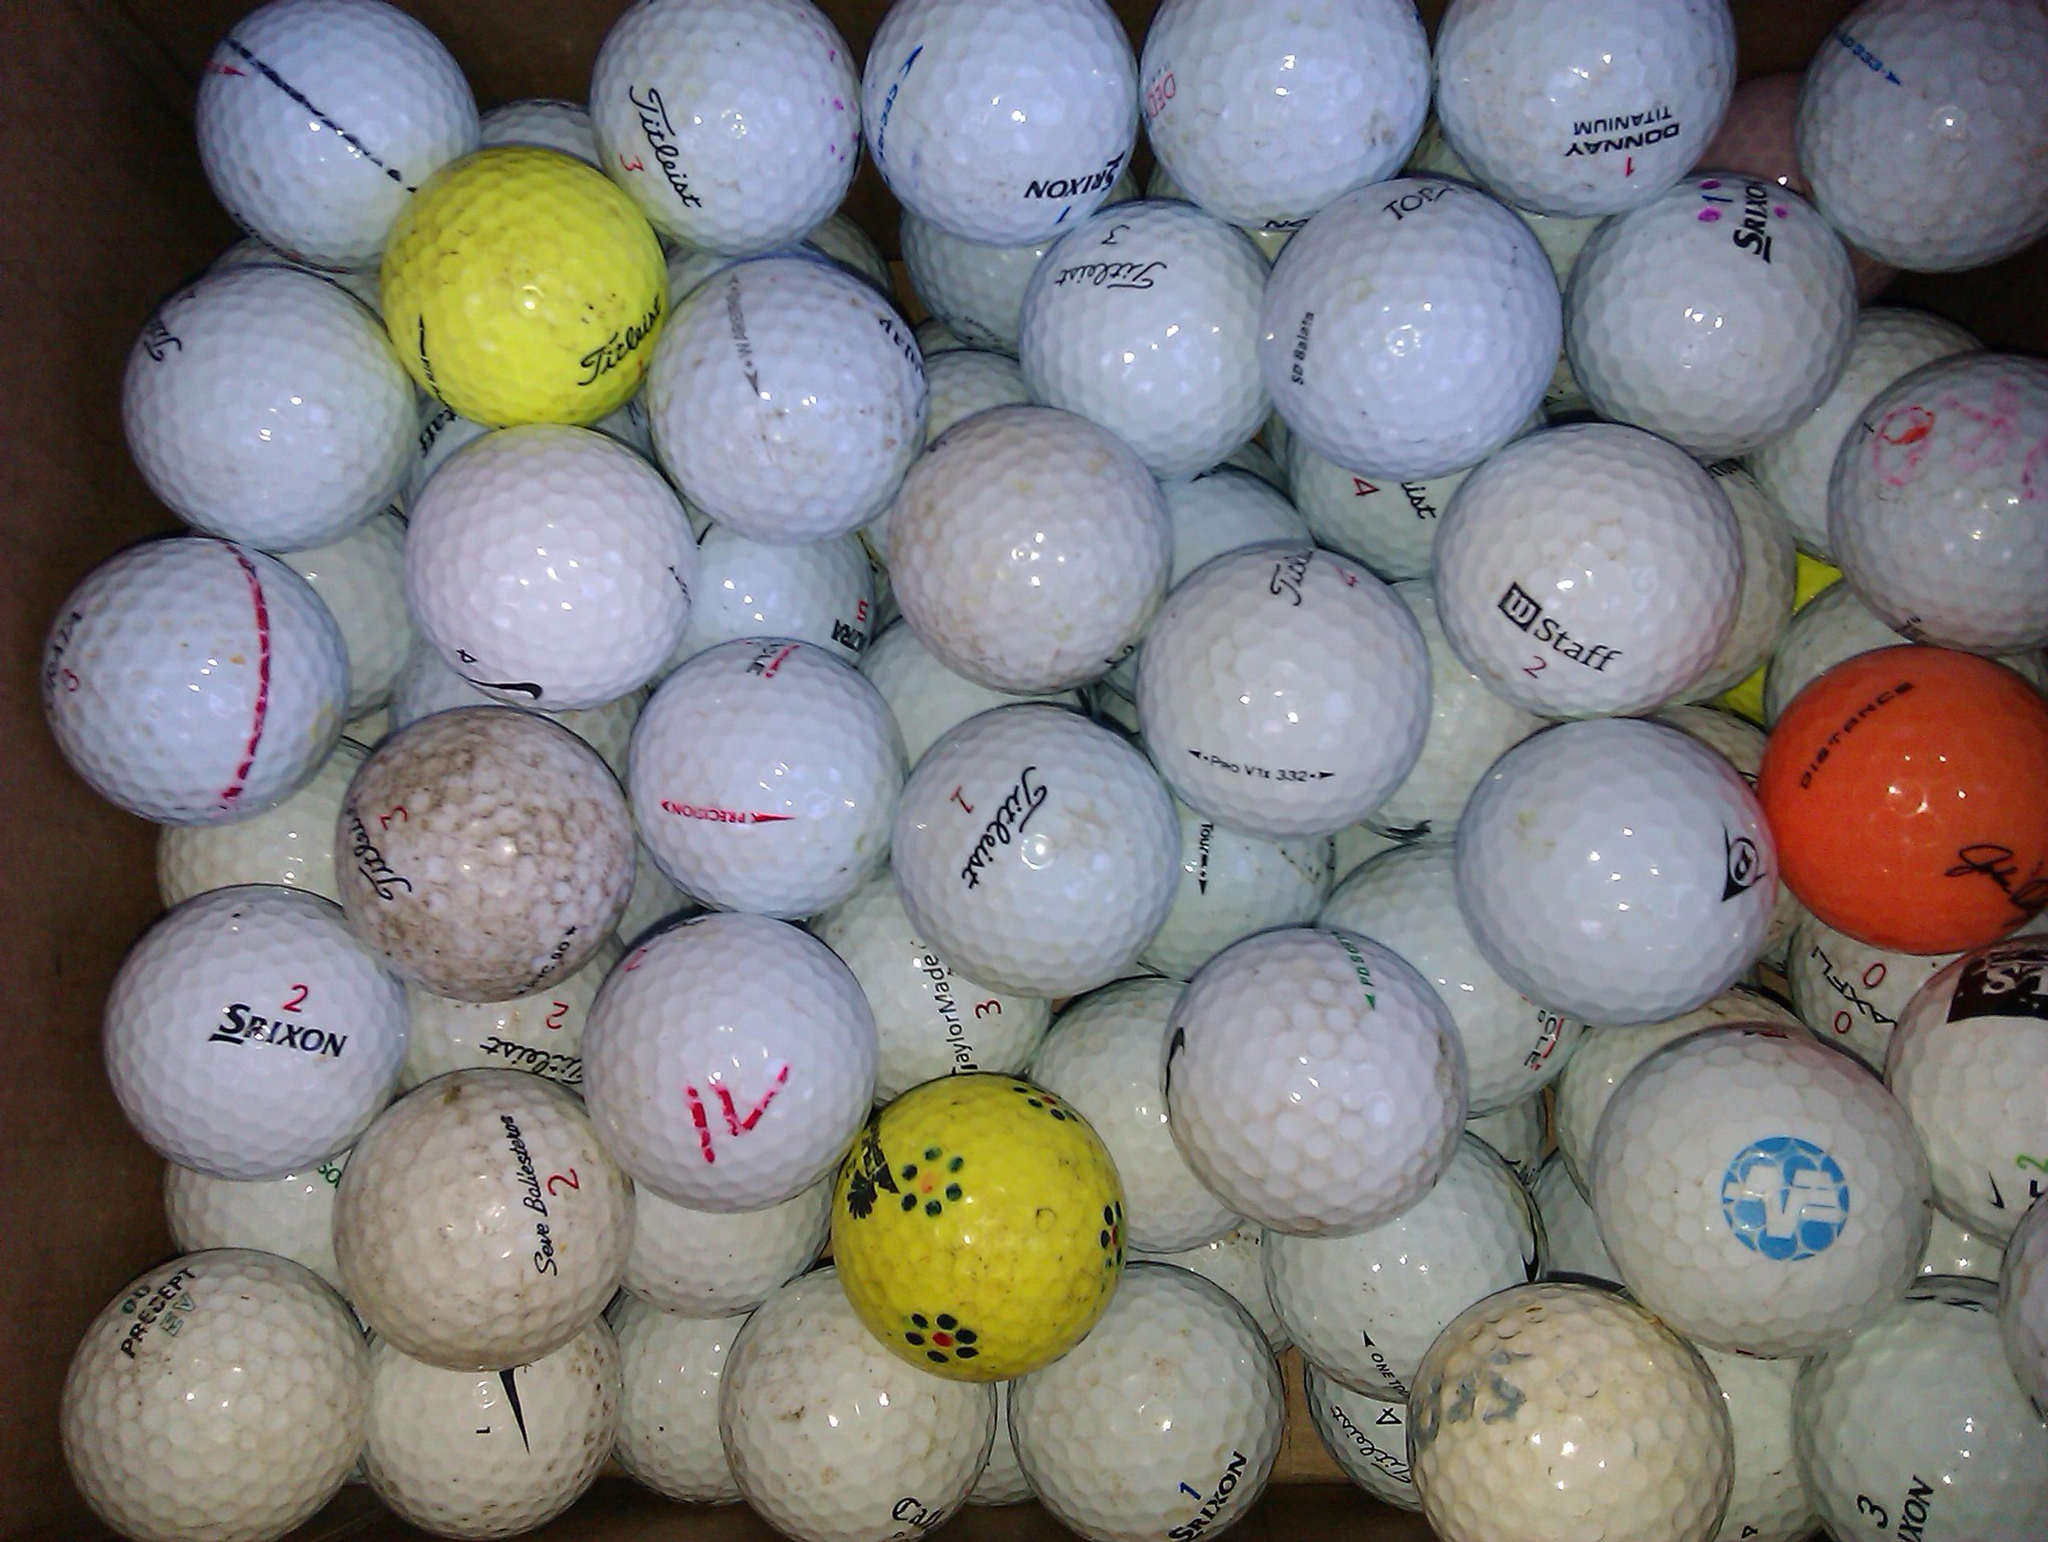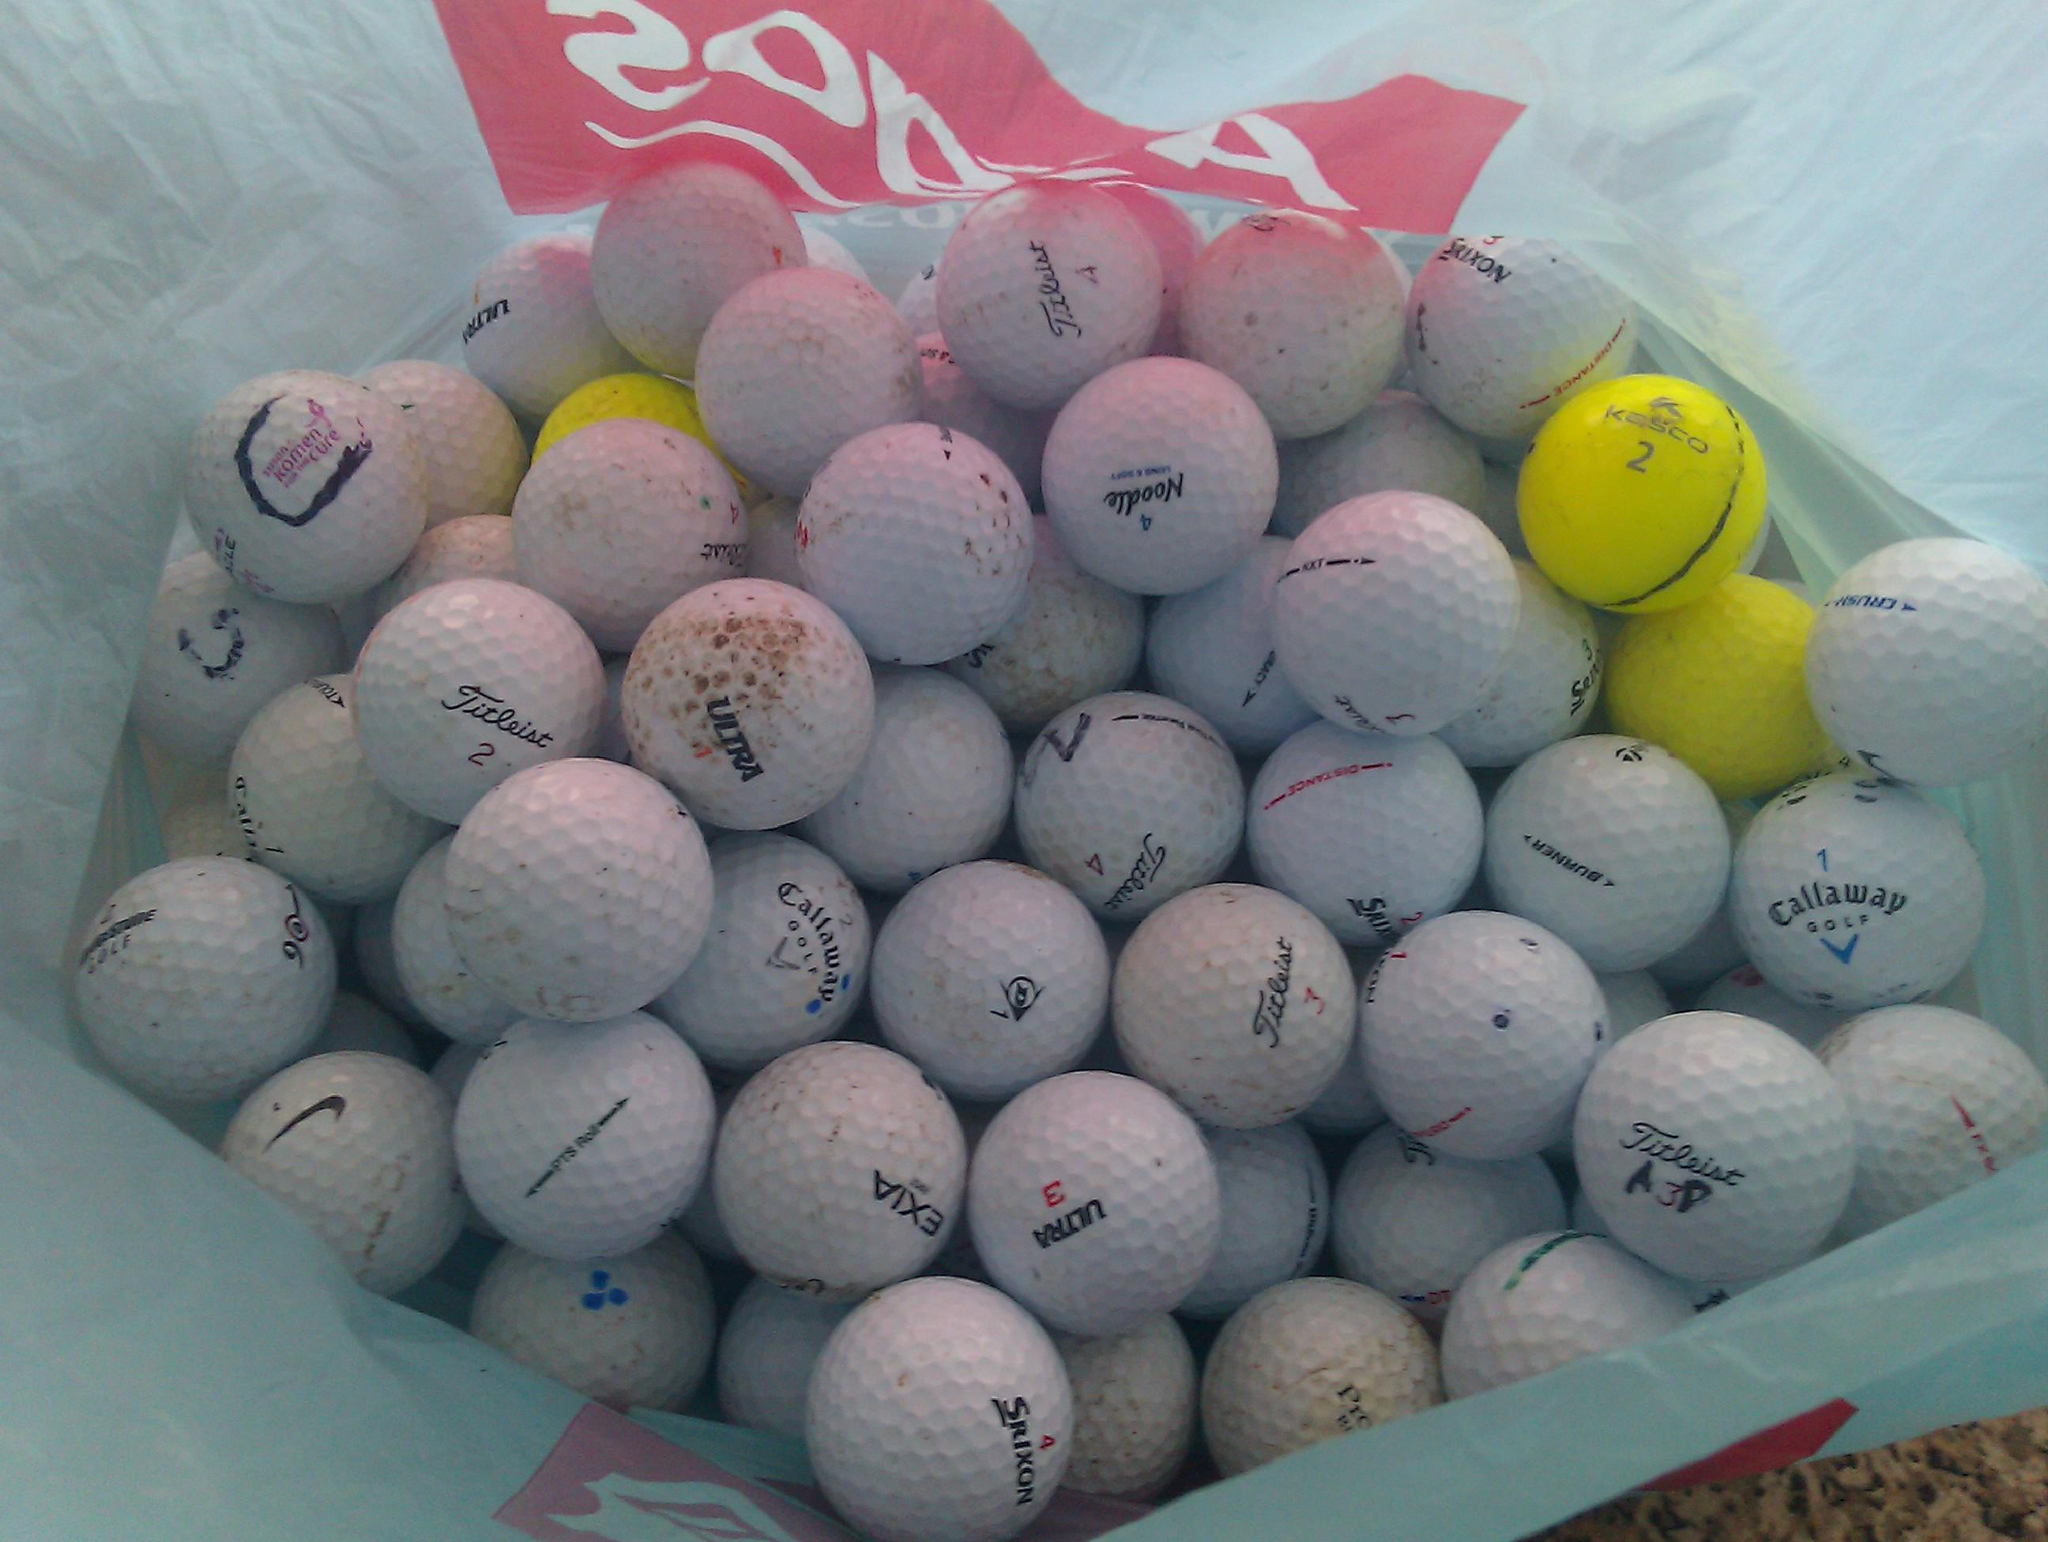The first image is the image on the left, the second image is the image on the right. Examine the images to the left and right. Is the description "There is at least one orange golf ball in the image on the left." accurate? Answer yes or no. Yes. The first image is the image on the left, the second image is the image on the right. Evaluate the accuracy of this statement regarding the images: "A collection of golf balls includes at least one bright orange ball, in one image.". Is it true? Answer yes or no. Yes. 